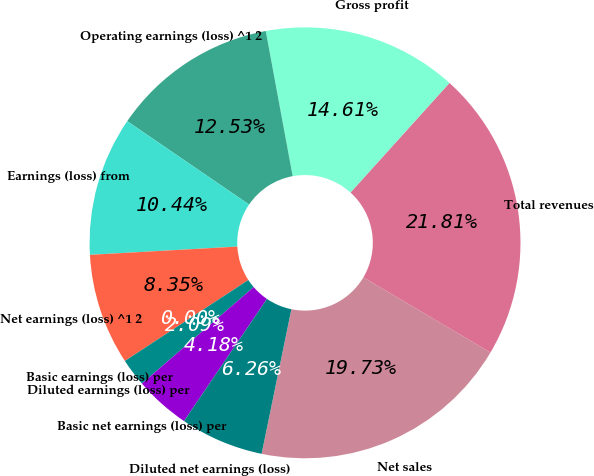<chart> <loc_0><loc_0><loc_500><loc_500><pie_chart><fcel>Net sales<fcel>Total revenues<fcel>Gross profit<fcel>Operating earnings (loss) ^1 2<fcel>Earnings (loss) from<fcel>Net earnings (loss) ^1 2<fcel>Basic earnings (loss) per<fcel>Diluted earnings (loss) per<fcel>Basic net earnings (loss) per<fcel>Diluted net earnings (loss)<nl><fcel>19.73%<fcel>21.81%<fcel>14.61%<fcel>12.53%<fcel>10.44%<fcel>8.35%<fcel>0.0%<fcel>2.09%<fcel>4.18%<fcel>6.26%<nl></chart> 